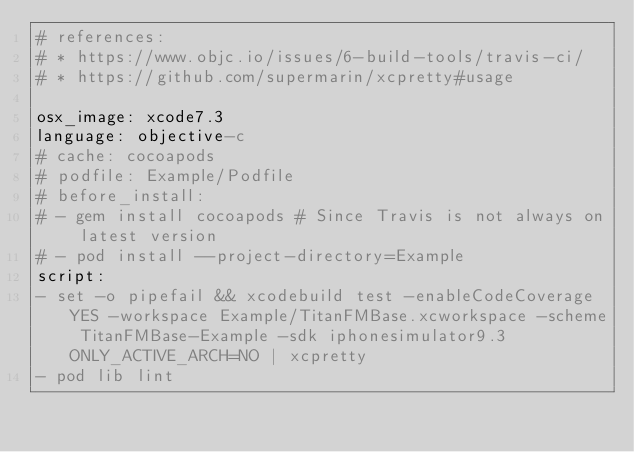<code> <loc_0><loc_0><loc_500><loc_500><_YAML_># references:
# * https://www.objc.io/issues/6-build-tools/travis-ci/
# * https://github.com/supermarin/xcpretty#usage

osx_image: xcode7.3
language: objective-c
# cache: cocoapods
# podfile: Example/Podfile
# before_install:
# - gem install cocoapods # Since Travis is not always on latest version
# - pod install --project-directory=Example
script:
- set -o pipefail && xcodebuild test -enableCodeCoverage YES -workspace Example/TitanFMBase.xcworkspace -scheme TitanFMBase-Example -sdk iphonesimulator9.3 ONLY_ACTIVE_ARCH=NO | xcpretty
- pod lib lint
</code> 